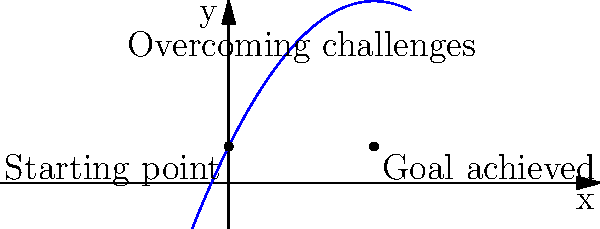In the workplace, you and your co-worker's journey of overcoming challenges together can be represented by a parabola. The graph above shows this parabola, where the x-axis represents time, and the y-axis represents the level of success or progress. If the equation of this parabola is $f(x) = -0.25x^2 + 2x + 1$, at what point in time (x-value) do you and your co-worker reach the peak of your combined efforts? To find the peak of the parabola, we need to follow these steps:

1) The peak of a parabola occurs at the axis of symmetry.

2) For a quadratic function in the form $f(x) = ax^2 + bx + c$, the x-coordinate of the axis of symmetry is given by the formula: $x = -\frac{b}{2a}$

3) In our equation $f(x) = -0.25x^2 + 2x + 1$:
   $a = -0.25$
   $b = 2$
   $c = 1$

4) Substituting into the formula:
   $x = -\frac{2}{2(-0.25)} = -\frac{2}{-0.5} = 4$

5) Therefore, the peak occurs when $x = 4$.

This means that you and your co-worker reach the peak of your combined efforts at time $x = 4$.
Answer: 4 